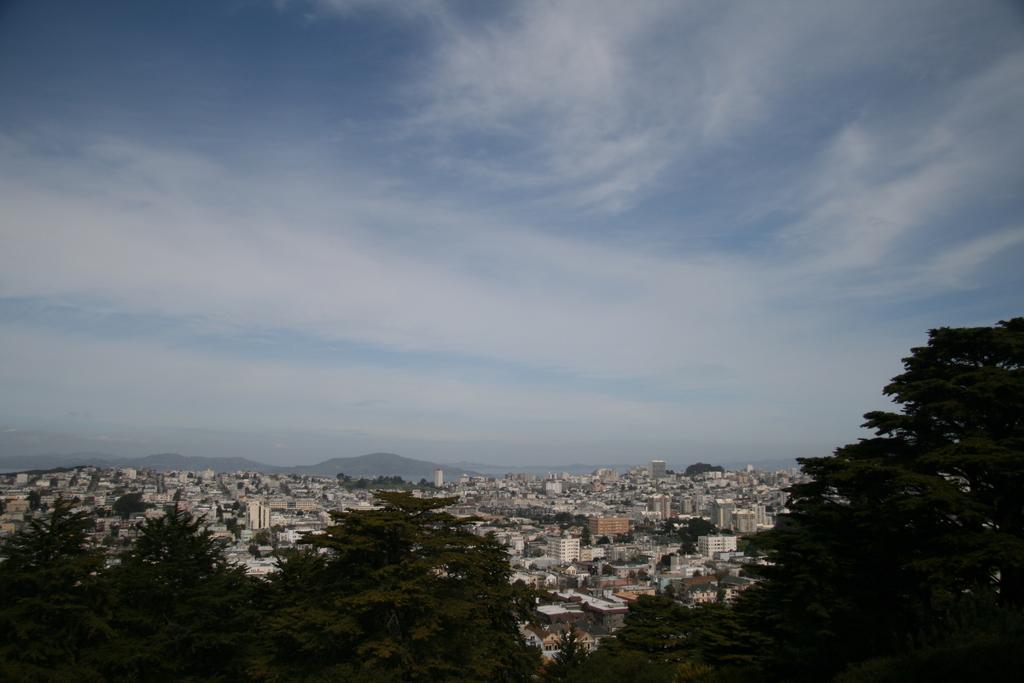Could you give a brief overview of what you see in this image? This is an outside view. At the bottom there are many trees and buildings. At the top of the image I can see the sky and clouds. 